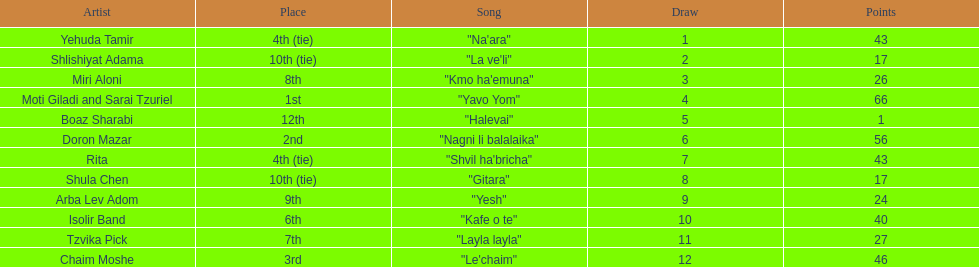What song is listed in the table right before layla layla? "Kafe o te". 